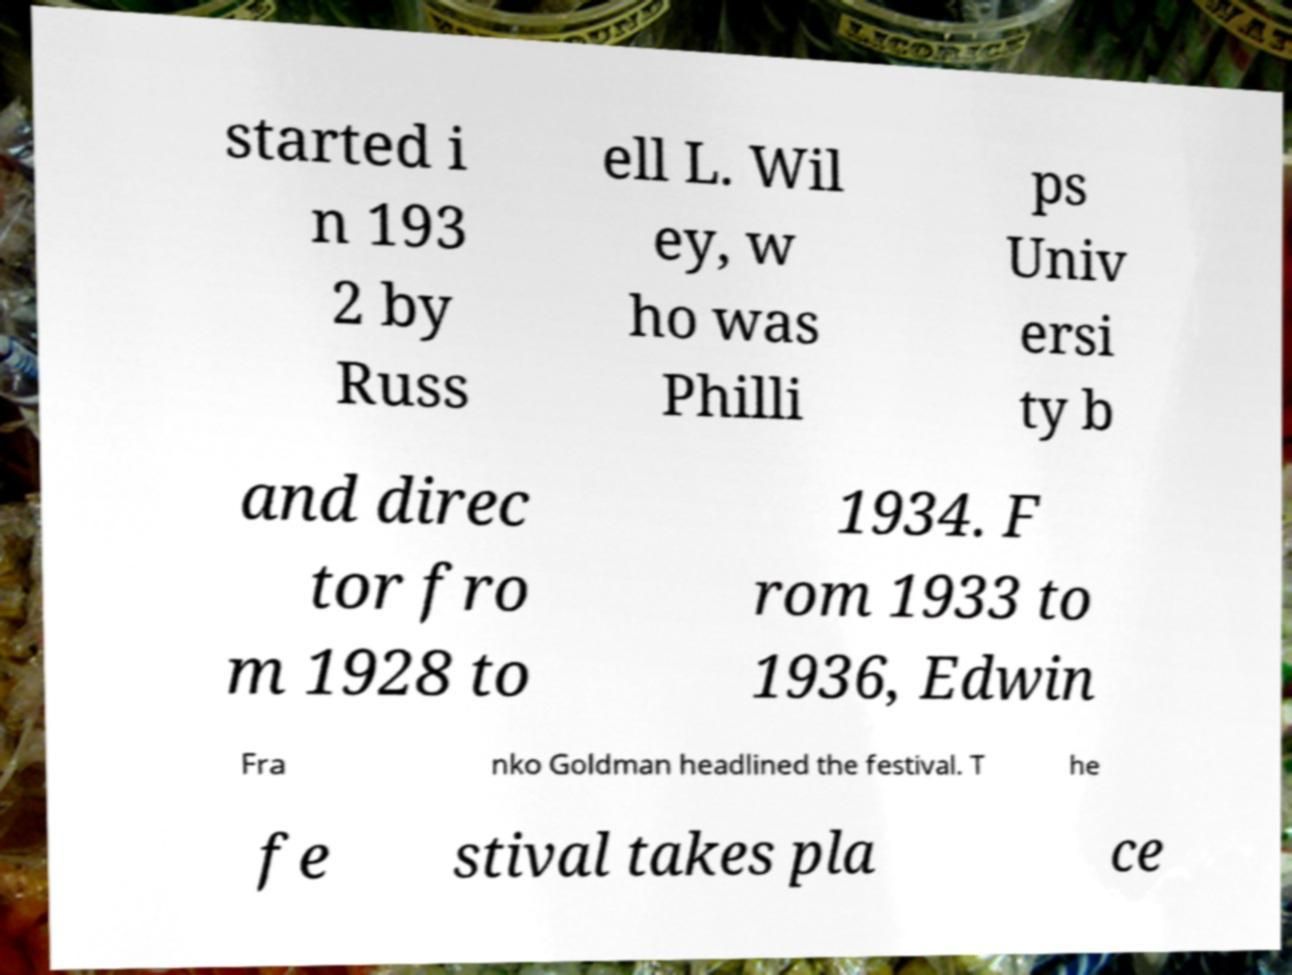Please identify and transcribe the text found in this image. started i n 193 2 by Russ ell L. Wil ey, w ho was Philli ps Univ ersi ty b and direc tor fro m 1928 to 1934. F rom 1933 to 1936, Edwin Fra nko Goldman headlined the festival. T he fe stival takes pla ce 